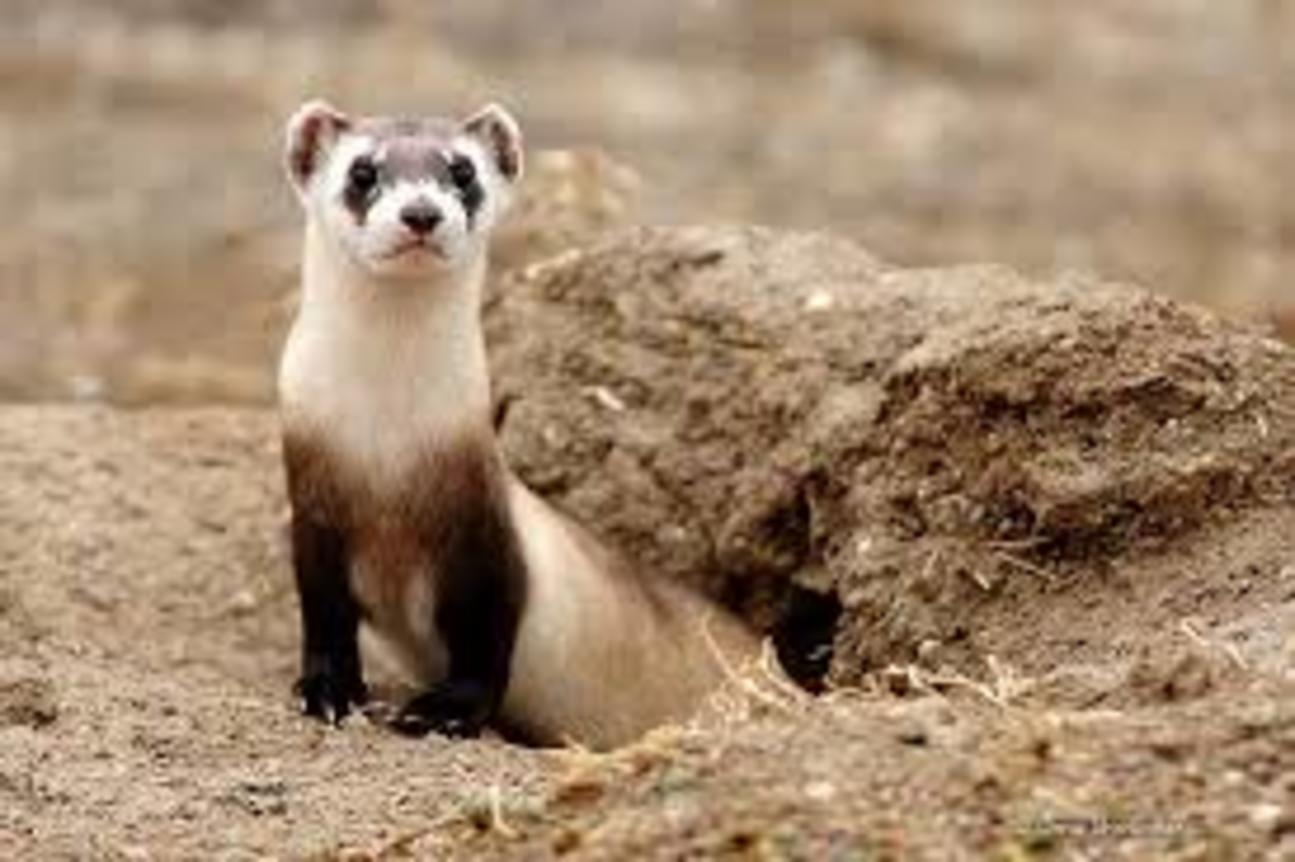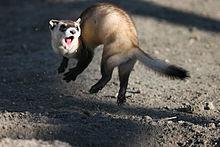The first image is the image on the left, the second image is the image on the right. Examine the images to the left and right. Is the description "Each image contains exactly one animal." accurate? Answer yes or no. Yes. The first image is the image on the left, the second image is the image on the right. Evaluate the accuracy of this statement regarding the images: "There are two animals". Is it true? Answer yes or no. Yes. 